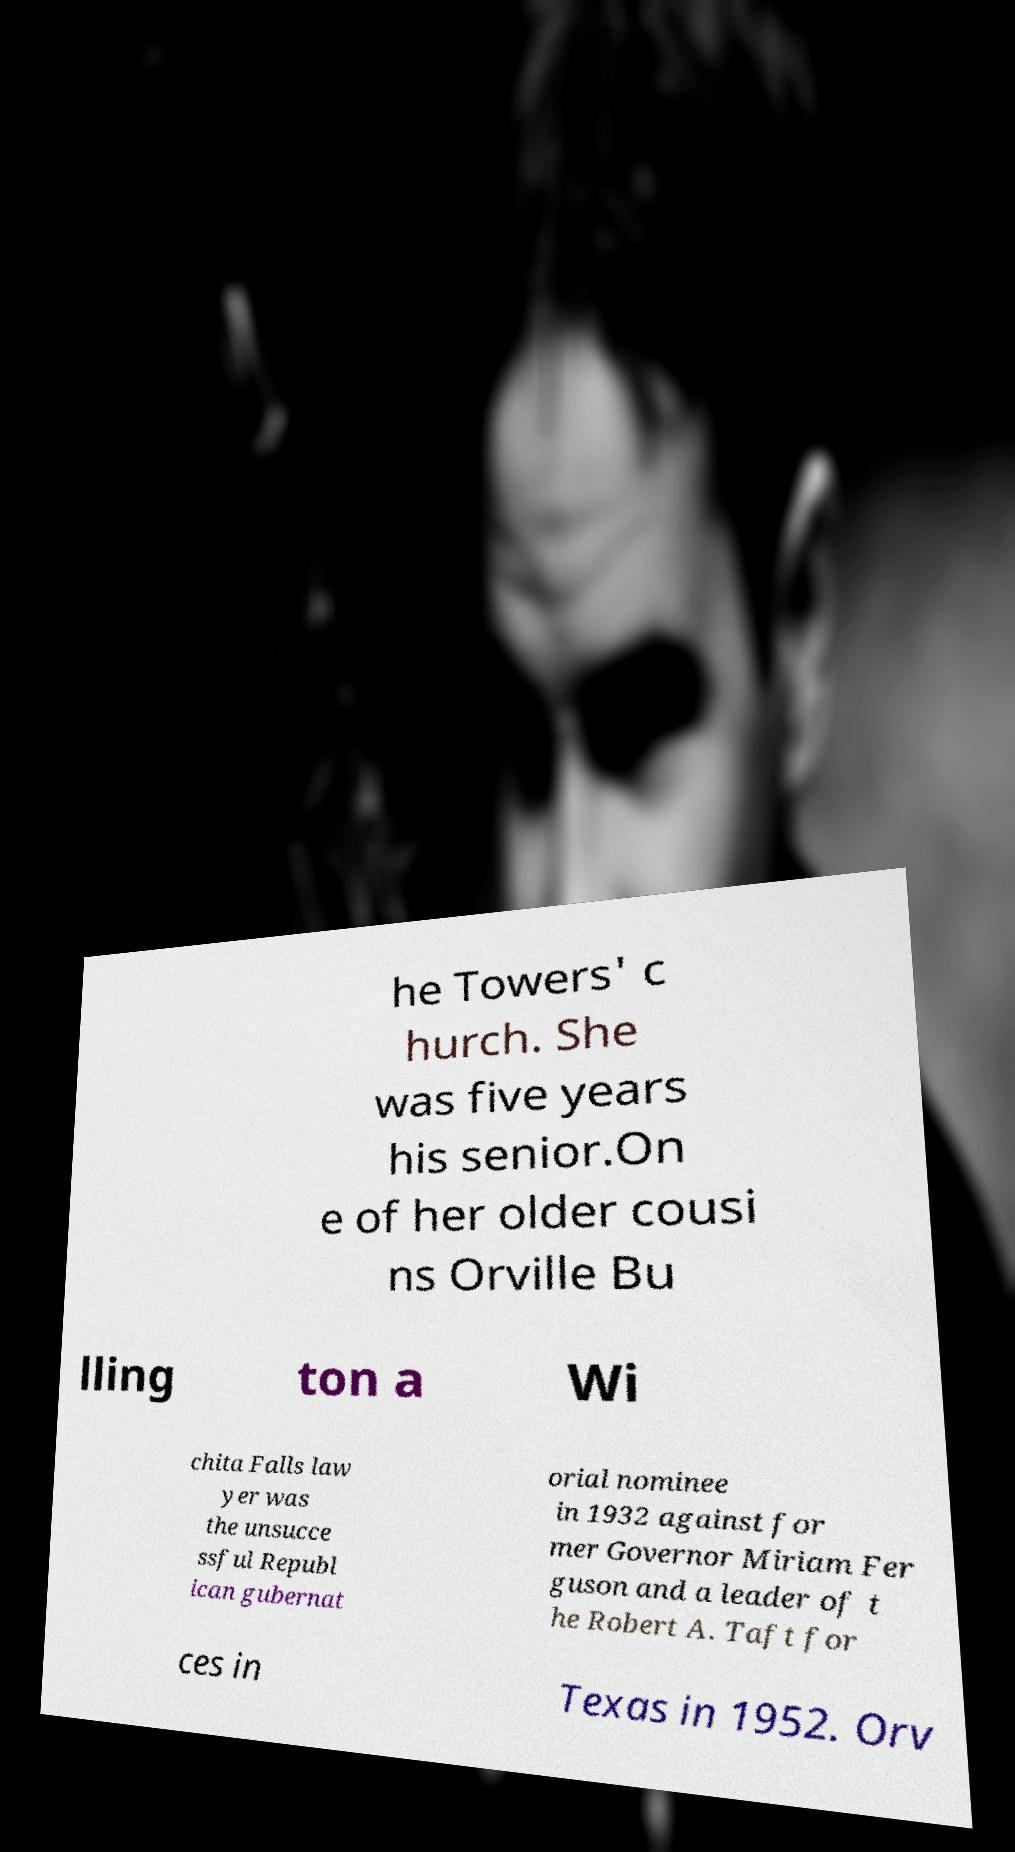Could you extract and type out the text from this image? he Towers' c hurch. She was five years his senior.On e of her older cousi ns Orville Bu lling ton a Wi chita Falls law yer was the unsucce ssful Republ ican gubernat orial nominee in 1932 against for mer Governor Miriam Fer guson and a leader of t he Robert A. Taft for ces in Texas in 1952. Orv 